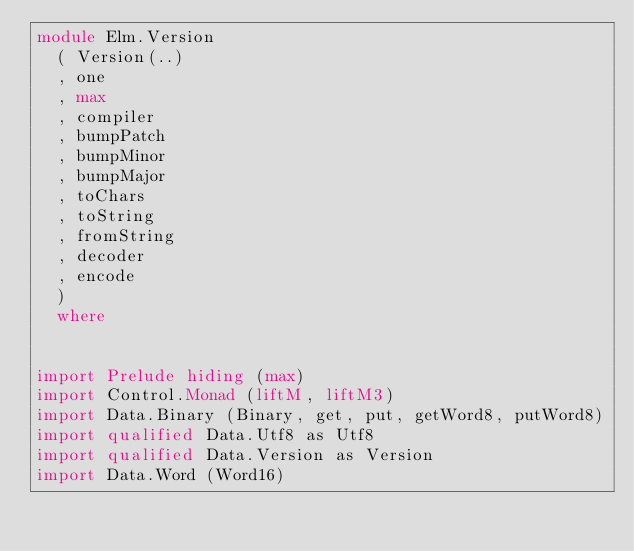Convert code to text. <code><loc_0><loc_0><loc_500><loc_500><_Haskell_>module Elm.Version
  ( Version(..)
  , one
  , max
  , compiler
  , bumpPatch
  , bumpMinor
  , bumpMajor
  , toChars
  , toString
  , fromString
  , decoder
  , encode
  )
  where


import Prelude hiding (max)
import Control.Monad (liftM, liftM3)
import Data.Binary (Binary, get, put, getWord8, putWord8)
import qualified Data.Utf8 as Utf8
import qualified Data.Version as Version
import Data.Word (Word16)</code> 